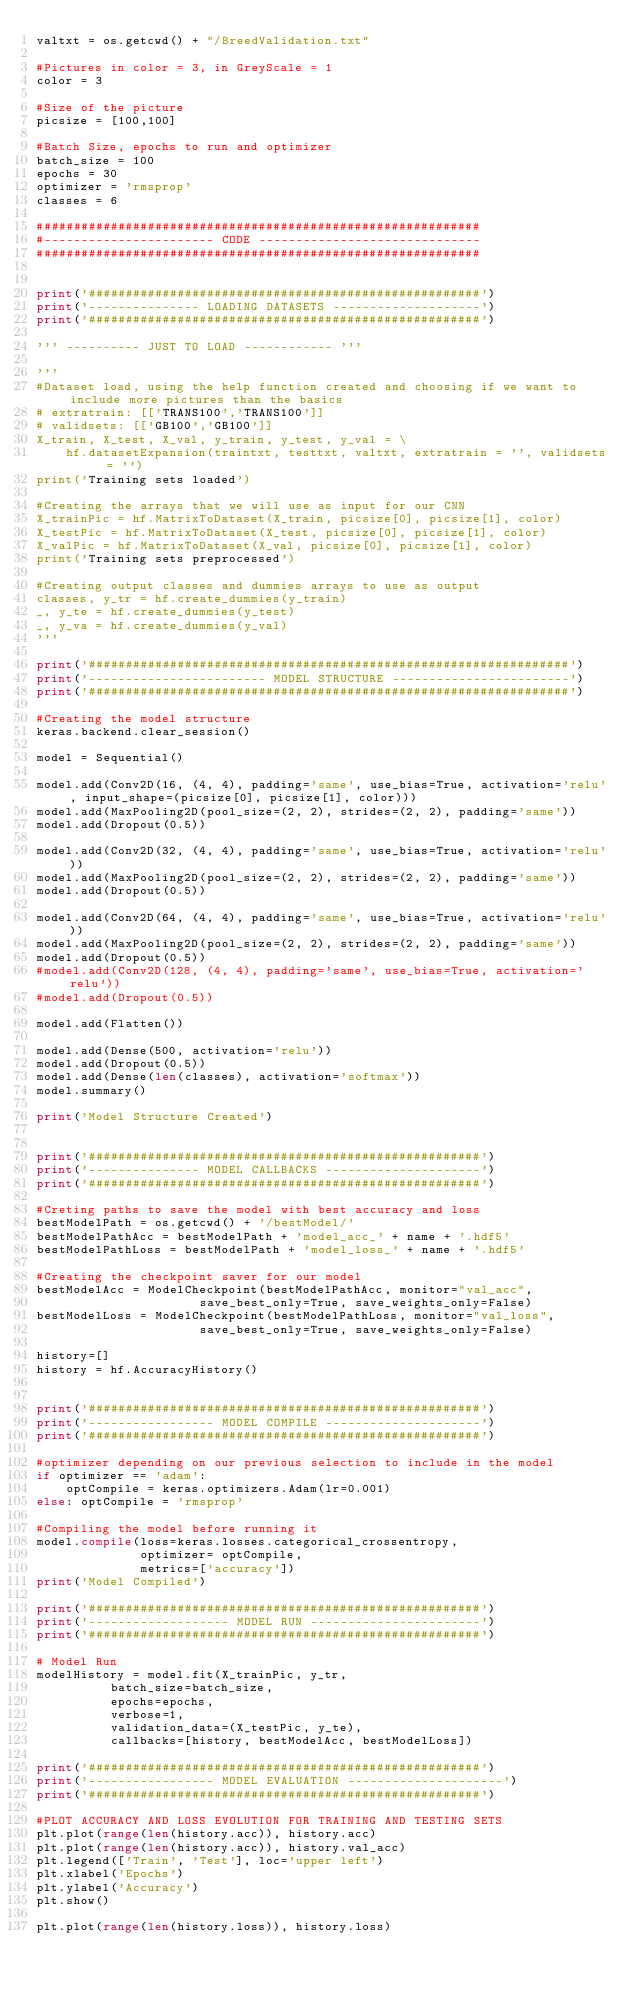Convert code to text. <code><loc_0><loc_0><loc_500><loc_500><_Python_>valtxt = os.getcwd() + "/BreedValidation.txt"

#Pictures in color = 3, in GreyScale = 1
color = 3

#Size of the picture
picsize = [100,100]

#Batch Size, epochs to run and optimizer
batch_size = 100
epochs = 30
optimizer = 'rmsprop'
classes = 6

############################################################
#----------------------- CODE ------------------------------
############################################################


print('#####################################################')
print('--------------- LOADING DATASETS --------------------')
print('#####################################################')

''' ---------- JUST TO LOAD ------------ '''

'''
#Dataset load, using the help function created and choosing if we want to include more pictures than the basics
# extratrain: [['TRANS100','TRANS100']]
# validsets: [['GB100','GB100']]
X_train, X_test, X_val, y_train, y_test, y_val = \
    hf.datasetExpansion(traintxt, testtxt, valtxt, extratrain = '', validsets = '')
print('Training sets loaded')

#Creating the arrays that we will use as input for our CNN
X_trainPic = hf.MatrixToDataset(X_train, picsize[0], picsize[1], color)
X_testPic = hf.MatrixToDataset(X_test, picsize[0], picsize[1], color)
X_valPic = hf.MatrixToDataset(X_val, picsize[0], picsize[1], color)
print('Training sets preprocessed')

#Creating output classes and dummies arrays to use as output
classes, y_tr = hf.create_dummies(y_train)
_, y_te = hf.create_dummies(y_test)
_, y_va = hf.create_dummies(y_val)
'''

print('#################################################################')
print('------------------------ MODEL STRUCTURE ------------------------')
print('#################################################################')

#Creating the model structure
keras.backend.clear_session()

model = Sequential()

model.add(Conv2D(16, (4, 4), padding='same', use_bias=True, activation='relu', input_shape=(picsize[0], picsize[1], color)))
model.add(MaxPooling2D(pool_size=(2, 2), strides=(2, 2), padding='same'))
model.add(Dropout(0.5))

model.add(Conv2D(32, (4, 4), padding='same', use_bias=True, activation='relu'))
model.add(MaxPooling2D(pool_size=(2, 2), strides=(2, 2), padding='same'))
model.add(Dropout(0.5))

model.add(Conv2D(64, (4, 4), padding='same', use_bias=True, activation='relu'))
model.add(MaxPooling2D(pool_size=(2, 2), strides=(2, 2), padding='same'))
model.add(Dropout(0.5))
#model.add(Conv2D(128, (4, 4), padding='same', use_bias=True, activation='relu'))
#model.add(Dropout(0.5))

model.add(Flatten())

model.add(Dense(500, activation='relu'))
model.add(Dropout(0.5))
model.add(Dense(len(classes), activation='softmax'))
model.summary()

print('Model Structure Created')


print('#####################################################')
print('--------------- MODEL CALLBACKS ---------------------')
print('#####################################################')

#Creting paths to save the model with best accuracy and loss
bestModelPath = os.getcwd() + '/bestModel/'
bestModelPathAcc = bestModelPath + 'model_acc_' + name + '.hdf5'
bestModelPathLoss = bestModelPath + 'model_loss_' + name + '.hdf5'

#Creating the checkpoint saver for our model
bestModelAcc = ModelCheckpoint(bestModelPathAcc, monitor="val_acc",
                      save_best_only=True, save_weights_only=False)
bestModelLoss = ModelCheckpoint(bestModelPathLoss, monitor="val_loss",
                      save_best_only=True, save_weights_only=False)

history=[]
history = hf.AccuracyHistory()


print('#####################################################')
print('----------------- MODEL COMPILE ---------------------')
print('#####################################################')

#optimizer depending on our previous selection to include in the model
if optimizer == 'adam':
    optCompile = keras.optimizers.Adam(lr=0.001)
else: optCompile = 'rmsprop'

#Compiling the model before running it
model.compile(loss=keras.losses.categorical_crossentropy,
              optimizer= optCompile,
              metrics=['accuracy'])
print('Model Compiled')

print('#####################################################')
print('------------------- MODEL RUN -----------------------')
print('#####################################################')

# Model Run
modelHistory = model.fit(X_trainPic, y_tr,
          batch_size=batch_size,
          epochs=epochs,
          verbose=1,
          validation_data=(X_testPic, y_te),
          callbacks=[history, bestModelAcc, bestModelLoss])

print('#####################################################')
print('----------------- MODEL EVALUATION ---------------------')
print('#####################################################')

#PLOT ACCURACY AND LOSS EVOLUTION FOR TRAINING AND TESTING SETS
plt.plot(range(len(history.acc)), history.acc)
plt.plot(range(len(history.acc)), history.val_acc)
plt.legend(['Train', 'Test'], loc='upper left')
plt.xlabel('Epochs')
plt.ylabel('Accuracy')
plt.show()

plt.plot(range(len(history.loss)), history.loss)</code> 